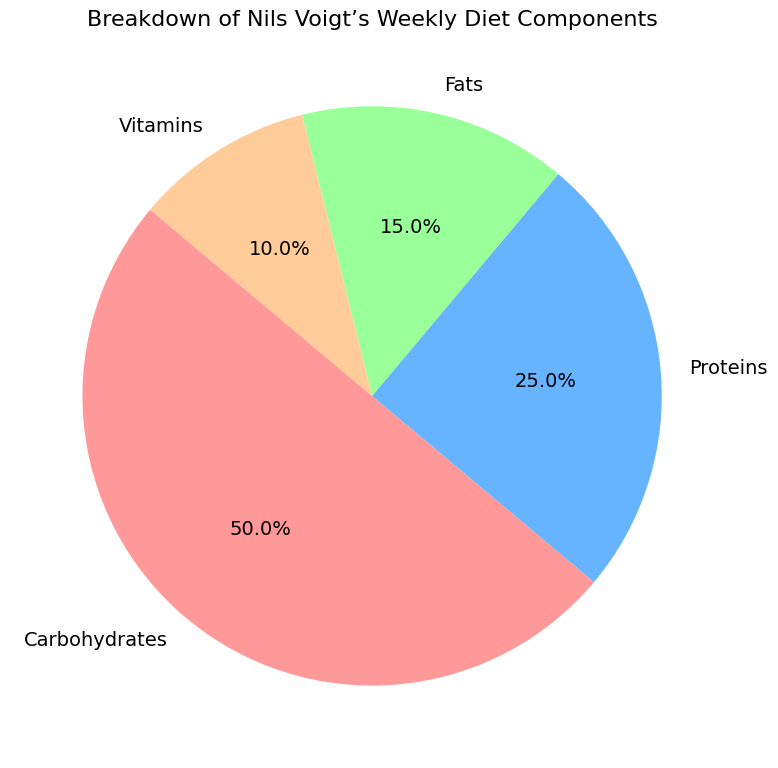Which nutrient makes up the majority of Nils Voigt's weekly diet? By looking at the pie chart, observe which nutrient's section is the largest. Carbohydrates occupy the largest segment.
Answer: Carbohydrates What is the combined percentage of Proteins and Fats in Nils Voigt's weekly diet? First, identify the percentages of Proteins and Fats from the chart. Proteins are 25%, and Fats are 15%. Adding these together gives 25% + 15% = 40%.
Answer: 40% Which nutrient has the smallest representation in Nils Voigt's diet? Identify the smallest segment of the pie chart. The smallest section is for Vitamins, which are 10%.
Answer: Vitamins How much more percentage do Carbohydrates contribute compared to Fats? Find the difference between the percentage of Carbohydrates and Fats. Carbohydrates are 50%, and Fats are 15%. The difference is 50% - 15% = 35%.
Answer: 35% What is the difference between the percentages of Carbohydrates and Proteins in Nils Voigt's diet? Subtract the percentage of Proteins from the percentage of Carbohydrates. Carbohydrates are 50%, and Proteins are 25%. The difference is 50% - 25% = 25%.
Answer: 25% Which two nutrients combined account for half of Nils Voigt's weekly diet? To find the combination that equals 50%, add the percentages of the nutrients given. Proteins and Carbohydrates together are 25% + 25%, making 50%.
Answer: Proteins and Carbohydrates If we grouped Fats and Vitamins together, what would be the total percentage of this group? Add the percentage values of Fats and Vitamins. Fats are 15% and Vitamins are 10%. The total is 15% + 10% = 25%.
Answer: 25% By how much does the percentage of Carbohydrates exceed the sum of the percentages of Fats and Vitamins? Calculate the sum of Fats and Vitamins, which is 15% + 10% = 25%. Subtract this sum from the percentage of Carbohydrates: 50% - 25% = 25%.
Answer: 25% What fraction of Nils Voigt’s diet is made up by Proteins compared to the whole diet? Proteins make up 25% of the diet. Since the whole diet is 100%, the fraction is 25/100, which simplifies to 1/4.
Answer: 1/4 